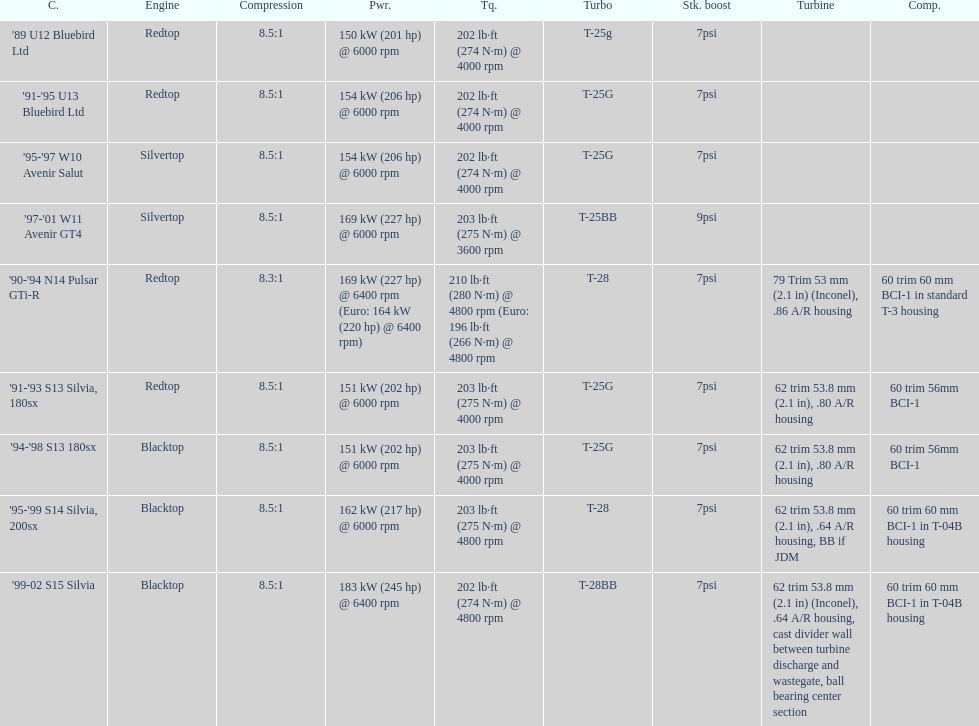Which car's power measured at higher than 6000 rpm? '90-'94 N14 Pulsar GTi-R, '99-02 S15 Silvia. 